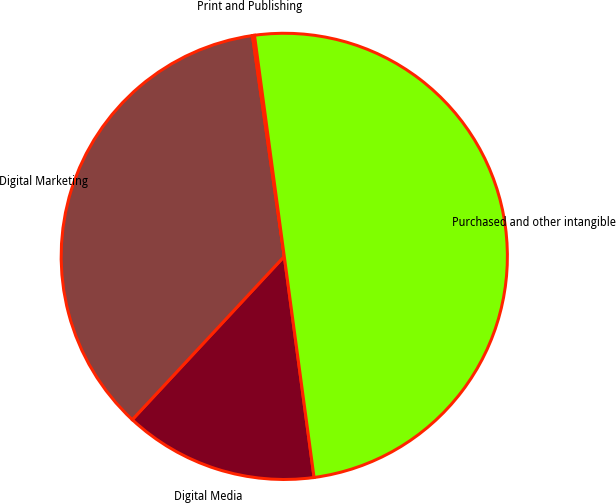Convert chart. <chart><loc_0><loc_0><loc_500><loc_500><pie_chart><fcel>Digital Media<fcel>Digital Marketing<fcel>Print and Publishing<fcel>Purchased and other intangible<nl><fcel>14.06%<fcel>35.79%<fcel>0.15%<fcel>50.0%<nl></chart> 